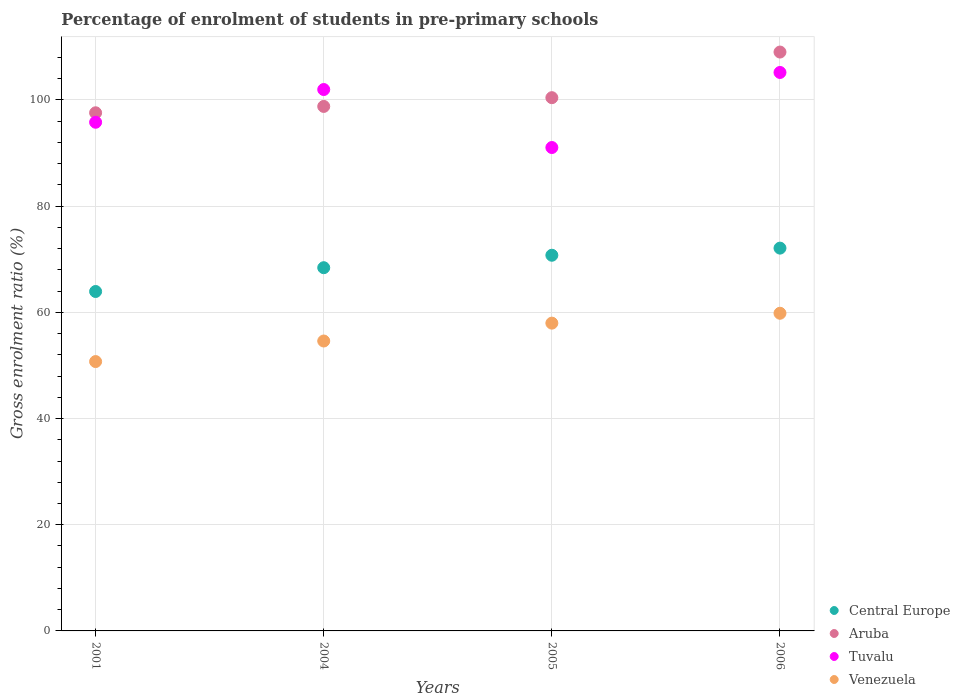Is the number of dotlines equal to the number of legend labels?
Keep it short and to the point. Yes. What is the percentage of students enrolled in pre-primary schools in Aruba in 2004?
Provide a succinct answer. 98.78. Across all years, what is the maximum percentage of students enrolled in pre-primary schools in Central Europe?
Your response must be concise. 72.09. Across all years, what is the minimum percentage of students enrolled in pre-primary schools in Central Europe?
Your answer should be compact. 63.93. What is the total percentage of students enrolled in pre-primary schools in Central Europe in the graph?
Your answer should be very brief. 275.18. What is the difference between the percentage of students enrolled in pre-primary schools in Venezuela in 2005 and that in 2006?
Your answer should be compact. -1.86. What is the difference between the percentage of students enrolled in pre-primary schools in Venezuela in 2001 and the percentage of students enrolled in pre-primary schools in Aruba in 2005?
Your answer should be very brief. -49.7. What is the average percentage of students enrolled in pre-primary schools in Tuvalu per year?
Give a very brief answer. 98.5. In the year 2004, what is the difference between the percentage of students enrolled in pre-primary schools in Tuvalu and percentage of students enrolled in pre-primary schools in Central Europe?
Your answer should be compact. 33.56. What is the ratio of the percentage of students enrolled in pre-primary schools in Central Europe in 2004 to that in 2006?
Provide a succinct answer. 0.95. Is the percentage of students enrolled in pre-primary schools in Venezuela in 2001 less than that in 2004?
Ensure brevity in your answer.  Yes. What is the difference between the highest and the second highest percentage of students enrolled in pre-primary schools in Central Europe?
Your response must be concise. 1.34. What is the difference between the highest and the lowest percentage of students enrolled in pre-primary schools in Venezuela?
Offer a terse response. 9.1. Is it the case that in every year, the sum of the percentage of students enrolled in pre-primary schools in Central Europe and percentage of students enrolled in pre-primary schools in Aruba  is greater than the sum of percentage of students enrolled in pre-primary schools in Tuvalu and percentage of students enrolled in pre-primary schools in Venezuela?
Provide a succinct answer. Yes. Is the percentage of students enrolled in pre-primary schools in Central Europe strictly less than the percentage of students enrolled in pre-primary schools in Aruba over the years?
Offer a terse response. Yes. How many years are there in the graph?
Offer a terse response. 4. What is the difference between two consecutive major ticks on the Y-axis?
Offer a terse response. 20. Does the graph contain grids?
Give a very brief answer. Yes. How are the legend labels stacked?
Keep it short and to the point. Vertical. What is the title of the graph?
Keep it short and to the point. Percentage of enrolment of students in pre-primary schools. What is the label or title of the X-axis?
Keep it short and to the point. Years. What is the Gross enrolment ratio (%) of Central Europe in 2001?
Your answer should be compact. 63.93. What is the Gross enrolment ratio (%) in Aruba in 2001?
Give a very brief answer. 97.58. What is the Gross enrolment ratio (%) in Tuvalu in 2001?
Your answer should be very brief. 95.8. What is the Gross enrolment ratio (%) of Venezuela in 2001?
Your answer should be very brief. 50.73. What is the Gross enrolment ratio (%) in Central Europe in 2004?
Provide a short and direct response. 68.41. What is the Gross enrolment ratio (%) in Aruba in 2004?
Provide a short and direct response. 98.78. What is the Gross enrolment ratio (%) in Tuvalu in 2004?
Your response must be concise. 101.96. What is the Gross enrolment ratio (%) of Venezuela in 2004?
Give a very brief answer. 54.6. What is the Gross enrolment ratio (%) in Central Europe in 2005?
Offer a terse response. 70.75. What is the Gross enrolment ratio (%) in Aruba in 2005?
Offer a very short reply. 100.43. What is the Gross enrolment ratio (%) of Tuvalu in 2005?
Provide a short and direct response. 91.04. What is the Gross enrolment ratio (%) of Venezuela in 2005?
Your answer should be compact. 57.97. What is the Gross enrolment ratio (%) of Central Europe in 2006?
Your answer should be very brief. 72.09. What is the Gross enrolment ratio (%) of Aruba in 2006?
Give a very brief answer. 109.02. What is the Gross enrolment ratio (%) of Tuvalu in 2006?
Your answer should be compact. 105.18. What is the Gross enrolment ratio (%) in Venezuela in 2006?
Your response must be concise. 59.83. Across all years, what is the maximum Gross enrolment ratio (%) of Central Europe?
Provide a short and direct response. 72.09. Across all years, what is the maximum Gross enrolment ratio (%) in Aruba?
Offer a very short reply. 109.02. Across all years, what is the maximum Gross enrolment ratio (%) in Tuvalu?
Ensure brevity in your answer.  105.18. Across all years, what is the maximum Gross enrolment ratio (%) of Venezuela?
Offer a very short reply. 59.83. Across all years, what is the minimum Gross enrolment ratio (%) of Central Europe?
Keep it short and to the point. 63.93. Across all years, what is the minimum Gross enrolment ratio (%) of Aruba?
Provide a short and direct response. 97.58. Across all years, what is the minimum Gross enrolment ratio (%) of Tuvalu?
Offer a terse response. 91.04. Across all years, what is the minimum Gross enrolment ratio (%) in Venezuela?
Your answer should be very brief. 50.73. What is the total Gross enrolment ratio (%) of Central Europe in the graph?
Your response must be concise. 275.18. What is the total Gross enrolment ratio (%) in Aruba in the graph?
Your response must be concise. 405.81. What is the total Gross enrolment ratio (%) of Tuvalu in the graph?
Offer a terse response. 393.98. What is the total Gross enrolment ratio (%) in Venezuela in the graph?
Offer a terse response. 223.12. What is the difference between the Gross enrolment ratio (%) in Central Europe in 2001 and that in 2004?
Make the answer very short. -4.48. What is the difference between the Gross enrolment ratio (%) in Aruba in 2001 and that in 2004?
Give a very brief answer. -1.2. What is the difference between the Gross enrolment ratio (%) of Tuvalu in 2001 and that in 2004?
Ensure brevity in your answer.  -6.16. What is the difference between the Gross enrolment ratio (%) of Venezuela in 2001 and that in 2004?
Your answer should be compact. -3.87. What is the difference between the Gross enrolment ratio (%) in Central Europe in 2001 and that in 2005?
Your answer should be very brief. -6.83. What is the difference between the Gross enrolment ratio (%) of Aruba in 2001 and that in 2005?
Provide a short and direct response. -2.84. What is the difference between the Gross enrolment ratio (%) in Tuvalu in 2001 and that in 2005?
Give a very brief answer. 4.76. What is the difference between the Gross enrolment ratio (%) of Venezuela in 2001 and that in 2005?
Offer a very short reply. -7.24. What is the difference between the Gross enrolment ratio (%) of Central Europe in 2001 and that in 2006?
Keep it short and to the point. -8.17. What is the difference between the Gross enrolment ratio (%) in Aruba in 2001 and that in 2006?
Provide a succinct answer. -11.44. What is the difference between the Gross enrolment ratio (%) in Tuvalu in 2001 and that in 2006?
Offer a very short reply. -9.38. What is the difference between the Gross enrolment ratio (%) of Venezuela in 2001 and that in 2006?
Provide a short and direct response. -9.1. What is the difference between the Gross enrolment ratio (%) of Central Europe in 2004 and that in 2005?
Offer a terse response. -2.35. What is the difference between the Gross enrolment ratio (%) of Aruba in 2004 and that in 2005?
Give a very brief answer. -1.65. What is the difference between the Gross enrolment ratio (%) of Tuvalu in 2004 and that in 2005?
Your answer should be very brief. 10.92. What is the difference between the Gross enrolment ratio (%) of Venezuela in 2004 and that in 2005?
Offer a terse response. -3.37. What is the difference between the Gross enrolment ratio (%) in Central Europe in 2004 and that in 2006?
Your answer should be very brief. -3.69. What is the difference between the Gross enrolment ratio (%) of Aruba in 2004 and that in 2006?
Give a very brief answer. -10.24. What is the difference between the Gross enrolment ratio (%) of Tuvalu in 2004 and that in 2006?
Provide a short and direct response. -3.21. What is the difference between the Gross enrolment ratio (%) of Venezuela in 2004 and that in 2006?
Provide a short and direct response. -5.23. What is the difference between the Gross enrolment ratio (%) of Central Europe in 2005 and that in 2006?
Your response must be concise. -1.34. What is the difference between the Gross enrolment ratio (%) in Aruba in 2005 and that in 2006?
Give a very brief answer. -8.59. What is the difference between the Gross enrolment ratio (%) in Tuvalu in 2005 and that in 2006?
Provide a short and direct response. -14.14. What is the difference between the Gross enrolment ratio (%) of Venezuela in 2005 and that in 2006?
Give a very brief answer. -1.86. What is the difference between the Gross enrolment ratio (%) of Central Europe in 2001 and the Gross enrolment ratio (%) of Aruba in 2004?
Ensure brevity in your answer.  -34.85. What is the difference between the Gross enrolment ratio (%) of Central Europe in 2001 and the Gross enrolment ratio (%) of Tuvalu in 2004?
Offer a very short reply. -38.04. What is the difference between the Gross enrolment ratio (%) of Central Europe in 2001 and the Gross enrolment ratio (%) of Venezuela in 2004?
Provide a short and direct response. 9.33. What is the difference between the Gross enrolment ratio (%) of Aruba in 2001 and the Gross enrolment ratio (%) of Tuvalu in 2004?
Your answer should be very brief. -4.38. What is the difference between the Gross enrolment ratio (%) of Aruba in 2001 and the Gross enrolment ratio (%) of Venezuela in 2004?
Give a very brief answer. 42.98. What is the difference between the Gross enrolment ratio (%) in Tuvalu in 2001 and the Gross enrolment ratio (%) in Venezuela in 2004?
Keep it short and to the point. 41.2. What is the difference between the Gross enrolment ratio (%) of Central Europe in 2001 and the Gross enrolment ratio (%) of Aruba in 2005?
Your answer should be compact. -36.5. What is the difference between the Gross enrolment ratio (%) of Central Europe in 2001 and the Gross enrolment ratio (%) of Tuvalu in 2005?
Keep it short and to the point. -27.11. What is the difference between the Gross enrolment ratio (%) of Central Europe in 2001 and the Gross enrolment ratio (%) of Venezuela in 2005?
Ensure brevity in your answer.  5.96. What is the difference between the Gross enrolment ratio (%) of Aruba in 2001 and the Gross enrolment ratio (%) of Tuvalu in 2005?
Make the answer very short. 6.54. What is the difference between the Gross enrolment ratio (%) of Aruba in 2001 and the Gross enrolment ratio (%) of Venezuela in 2005?
Your response must be concise. 39.62. What is the difference between the Gross enrolment ratio (%) of Tuvalu in 2001 and the Gross enrolment ratio (%) of Venezuela in 2005?
Offer a very short reply. 37.83. What is the difference between the Gross enrolment ratio (%) in Central Europe in 2001 and the Gross enrolment ratio (%) in Aruba in 2006?
Provide a short and direct response. -45.09. What is the difference between the Gross enrolment ratio (%) in Central Europe in 2001 and the Gross enrolment ratio (%) in Tuvalu in 2006?
Give a very brief answer. -41.25. What is the difference between the Gross enrolment ratio (%) of Central Europe in 2001 and the Gross enrolment ratio (%) of Venezuela in 2006?
Your answer should be very brief. 4.1. What is the difference between the Gross enrolment ratio (%) in Aruba in 2001 and the Gross enrolment ratio (%) in Tuvalu in 2006?
Offer a terse response. -7.59. What is the difference between the Gross enrolment ratio (%) of Aruba in 2001 and the Gross enrolment ratio (%) of Venezuela in 2006?
Ensure brevity in your answer.  37.76. What is the difference between the Gross enrolment ratio (%) in Tuvalu in 2001 and the Gross enrolment ratio (%) in Venezuela in 2006?
Provide a short and direct response. 35.97. What is the difference between the Gross enrolment ratio (%) of Central Europe in 2004 and the Gross enrolment ratio (%) of Aruba in 2005?
Ensure brevity in your answer.  -32.02. What is the difference between the Gross enrolment ratio (%) of Central Europe in 2004 and the Gross enrolment ratio (%) of Tuvalu in 2005?
Ensure brevity in your answer.  -22.63. What is the difference between the Gross enrolment ratio (%) of Central Europe in 2004 and the Gross enrolment ratio (%) of Venezuela in 2005?
Offer a terse response. 10.44. What is the difference between the Gross enrolment ratio (%) of Aruba in 2004 and the Gross enrolment ratio (%) of Tuvalu in 2005?
Keep it short and to the point. 7.74. What is the difference between the Gross enrolment ratio (%) of Aruba in 2004 and the Gross enrolment ratio (%) of Venezuela in 2005?
Keep it short and to the point. 40.81. What is the difference between the Gross enrolment ratio (%) in Tuvalu in 2004 and the Gross enrolment ratio (%) in Venezuela in 2005?
Offer a terse response. 44. What is the difference between the Gross enrolment ratio (%) in Central Europe in 2004 and the Gross enrolment ratio (%) in Aruba in 2006?
Offer a very short reply. -40.61. What is the difference between the Gross enrolment ratio (%) of Central Europe in 2004 and the Gross enrolment ratio (%) of Tuvalu in 2006?
Your answer should be compact. -36.77. What is the difference between the Gross enrolment ratio (%) of Central Europe in 2004 and the Gross enrolment ratio (%) of Venezuela in 2006?
Make the answer very short. 8.58. What is the difference between the Gross enrolment ratio (%) of Aruba in 2004 and the Gross enrolment ratio (%) of Tuvalu in 2006?
Your answer should be compact. -6.4. What is the difference between the Gross enrolment ratio (%) of Aruba in 2004 and the Gross enrolment ratio (%) of Venezuela in 2006?
Make the answer very short. 38.95. What is the difference between the Gross enrolment ratio (%) in Tuvalu in 2004 and the Gross enrolment ratio (%) in Venezuela in 2006?
Your answer should be compact. 42.14. What is the difference between the Gross enrolment ratio (%) in Central Europe in 2005 and the Gross enrolment ratio (%) in Aruba in 2006?
Keep it short and to the point. -38.27. What is the difference between the Gross enrolment ratio (%) in Central Europe in 2005 and the Gross enrolment ratio (%) in Tuvalu in 2006?
Offer a terse response. -34.43. What is the difference between the Gross enrolment ratio (%) of Central Europe in 2005 and the Gross enrolment ratio (%) of Venezuela in 2006?
Your answer should be compact. 10.93. What is the difference between the Gross enrolment ratio (%) in Aruba in 2005 and the Gross enrolment ratio (%) in Tuvalu in 2006?
Make the answer very short. -4.75. What is the difference between the Gross enrolment ratio (%) of Aruba in 2005 and the Gross enrolment ratio (%) of Venezuela in 2006?
Offer a terse response. 40.6. What is the difference between the Gross enrolment ratio (%) in Tuvalu in 2005 and the Gross enrolment ratio (%) in Venezuela in 2006?
Keep it short and to the point. 31.21. What is the average Gross enrolment ratio (%) of Central Europe per year?
Provide a short and direct response. 68.79. What is the average Gross enrolment ratio (%) in Aruba per year?
Your answer should be compact. 101.45. What is the average Gross enrolment ratio (%) in Tuvalu per year?
Provide a short and direct response. 98.5. What is the average Gross enrolment ratio (%) of Venezuela per year?
Make the answer very short. 55.78. In the year 2001, what is the difference between the Gross enrolment ratio (%) of Central Europe and Gross enrolment ratio (%) of Aruba?
Give a very brief answer. -33.66. In the year 2001, what is the difference between the Gross enrolment ratio (%) in Central Europe and Gross enrolment ratio (%) in Tuvalu?
Your answer should be compact. -31.87. In the year 2001, what is the difference between the Gross enrolment ratio (%) of Central Europe and Gross enrolment ratio (%) of Venezuela?
Make the answer very short. 13.2. In the year 2001, what is the difference between the Gross enrolment ratio (%) in Aruba and Gross enrolment ratio (%) in Tuvalu?
Your answer should be very brief. 1.78. In the year 2001, what is the difference between the Gross enrolment ratio (%) in Aruba and Gross enrolment ratio (%) in Venezuela?
Your answer should be very brief. 46.85. In the year 2001, what is the difference between the Gross enrolment ratio (%) of Tuvalu and Gross enrolment ratio (%) of Venezuela?
Keep it short and to the point. 45.07. In the year 2004, what is the difference between the Gross enrolment ratio (%) of Central Europe and Gross enrolment ratio (%) of Aruba?
Keep it short and to the point. -30.37. In the year 2004, what is the difference between the Gross enrolment ratio (%) in Central Europe and Gross enrolment ratio (%) in Tuvalu?
Give a very brief answer. -33.56. In the year 2004, what is the difference between the Gross enrolment ratio (%) in Central Europe and Gross enrolment ratio (%) in Venezuela?
Keep it short and to the point. 13.81. In the year 2004, what is the difference between the Gross enrolment ratio (%) of Aruba and Gross enrolment ratio (%) of Tuvalu?
Offer a very short reply. -3.18. In the year 2004, what is the difference between the Gross enrolment ratio (%) in Aruba and Gross enrolment ratio (%) in Venezuela?
Give a very brief answer. 44.18. In the year 2004, what is the difference between the Gross enrolment ratio (%) of Tuvalu and Gross enrolment ratio (%) of Venezuela?
Your response must be concise. 47.36. In the year 2005, what is the difference between the Gross enrolment ratio (%) in Central Europe and Gross enrolment ratio (%) in Aruba?
Provide a succinct answer. -29.68. In the year 2005, what is the difference between the Gross enrolment ratio (%) of Central Europe and Gross enrolment ratio (%) of Tuvalu?
Keep it short and to the point. -20.29. In the year 2005, what is the difference between the Gross enrolment ratio (%) in Central Europe and Gross enrolment ratio (%) in Venezuela?
Provide a short and direct response. 12.79. In the year 2005, what is the difference between the Gross enrolment ratio (%) of Aruba and Gross enrolment ratio (%) of Tuvalu?
Offer a very short reply. 9.39. In the year 2005, what is the difference between the Gross enrolment ratio (%) of Aruba and Gross enrolment ratio (%) of Venezuela?
Offer a very short reply. 42.46. In the year 2005, what is the difference between the Gross enrolment ratio (%) in Tuvalu and Gross enrolment ratio (%) in Venezuela?
Provide a short and direct response. 33.07. In the year 2006, what is the difference between the Gross enrolment ratio (%) in Central Europe and Gross enrolment ratio (%) in Aruba?
Your response must be concise. -36.93. In the year 2006, what is the difference between the Gross enrolment ratio (%) in Central Europe and Gross enrolment ratio (%) in Tuvalu?
Your answer should be compact. -33.08. In the year 2006, what is the difference between the Gross enrolment ratio (%) in Central Europe and Gross enrolment ratio (%) in Venezuela?
Your response must be concise. 12.27. In the year 2006, what is the difference between the Gross enrolment ratio (%) in Aruba and Gross enrolment ratio (%) in Tuvalu?
Your answer should be very brief. 3.84. In the year 2006, what is the difference between the Gross enrolment ratio (%) in Aruba and Gross enrolment ratio (%) in Venezuela?
Make the answer very short. 49.19. In the year 2006, what is the difference between the Gross enrolment ratio (%) of Tuvalu and Gross enrolment ratio (%) of Venezuela?
Your response must be concise. 45.35. What is the ratio of the Gross enrolment ratio (%) of Central Europe in 2001 to that in 2004?
Your response must be concise. 0.93. What is the ratio of the Gross enrolment ratio (%) of Aruba in 2001 to that in 2004?
Give a very brief answer. 0.99. What is the ratio of the Gross enrolment ratio (%) in Tuvalu in 2001 to that in 2004?
Give a very brief answer. 0.94. What is the ratio of the Gross enrolment ratio (%) in Venezuela in 2001 to that in 2004?
Provide a succinct answer. 0.93. What is the ratio of the Gross enrolment ratio (%) of Central Europe in 2001 to that in 2005?
Ensure brevity in your answer.  0.9. What is the ratio of the Gross enrolment ratio (%) of Aruba in 2001 to that in 2005?
Offer a terse response. 0.97. What is the ratio of the Gross enrolment ratio (%) of Tuvalu in 2001 to that in 2005?
Ensure brevity in your answer.  1.05. What is the ratio of the Gross enrolment ratio (%) of Venezuela in 2001 to that in 2005?
Your answer should be very brief. 0.88. What is the ratio of the Gross enrolment ratio (%) of Central Europe in 2001 to that in 2006?
Offer a very short reply. 0.89. What is the ratio of the Gross enrolment ratio (%) in Aruba in 2001 to that in 2006?
Offer a terse response. 0.9. What is the ratio of the Gross enrolment ratio (%) of Tuvalu in 2001 to that in 2006?
Make the answer very short. 0.91. What is the ratio of the Gross enrolment ratio (%) in Venezuela in 2001 to that in 2006?
Give a very brief answer. 0.85. What is the ratio of the Gross enrolment ratio (%) in Central Europe in 2004 to that in 2005?
Provide a short and direct response. 0.97. What is the ratio of the Gross enrolment ratio (%) in Aruba in 2004 to that in 2005?
Give a very brief answer. 0.98. What is the ratio of the Gross enrolment ratio (%) of Tuvalu in 2004 to that in 2005?
Give a very brief answer. 1.12. What is the ratio of the Gross enrolment ratio (%) of Venezuela in 2004 to that in 2005?
Give a very brief answer. 0.94. What is the ratio of the Gross enrolment ratio (%) in Central Europe in 2004 to that in 2006?
Offer a very short reply. 0.95. What is the ratio of the Gross enrolment ratio (%) of Aruba in 2004 to that in 2006?
Provide a succinct answer. 0.91. What is the ratio of the Gross enrolment ratio (%) in Tuvalu in 2004 to that in 2006?
Provide a short and direct response. 0.97. What is the ratio of the Gross enrolment ratio (%) of Venezuela in 2004 to that in 2006?
Keep it short and to the point. 0.91. What is the ratio of the Gross enrolment ratio (%) of Central Europe in 2005 to that in 2006?
Your response must be concise. 0.98. What is the ratio of the Gross enrolment ratio (%) in Aruba in 2005 to that in 2006?
Provide a succinct answer. 0.92. What is the ratio of the Gross enrolment ratio (%) in Tuvalu in 2005 to that in 2006?
Give a very brief answer. 0.87. What is the ratio of the Gross enrolment ratio (%) of Venezuela in 2005 to that in 2006?
Make the answer very short. 0.97. What is the difference between the highest and the second highest Gross enrolment ratio (%) in Central Europe?
Your answer should be compact. 1.34. What is the difference between the highest and the second highest Gross enrolment ratio (%) of Aruba?
Provide a succinct answer. 8.59. What is the difference between the highest and the second highest Gross enrolment ratio (%) in Tuvalu?
Your answer should be very brief. 3.21. What is the difference between the highest and the second highest Gross enrolment ratio (%) of Venezuela?
Ensure brevity in your answer.  1.86. What is the difference between the highest and the lowest Gross enrolment ratio (%) of Central Europe?
Provide a succinct answer. 8.17. What is the difference between the highest and the lowest Gross enrolment ratio (%) in Aruba?
Provide a succinct answer. 11.44. What is the difference between the highest and the lowest Gross enrolment ratio (%) in Tuvalu?
Give a very brief answer. 14.14. What is the difference between the highest and the lowest Gross enrolment ratio (%) in Venezuela?
Ensure brevity in your answer.  9.1. 